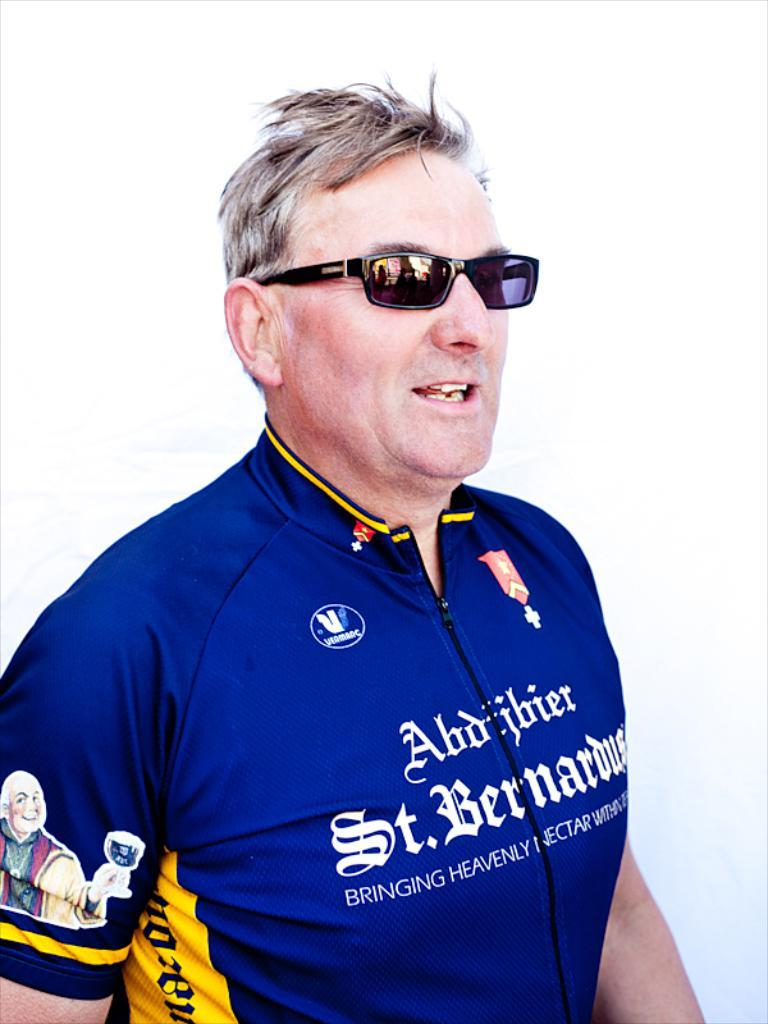<image>
Create a compact narrative representing the image presented. A man in a shirt that says St. Bernardus is wearing sunglasses. 